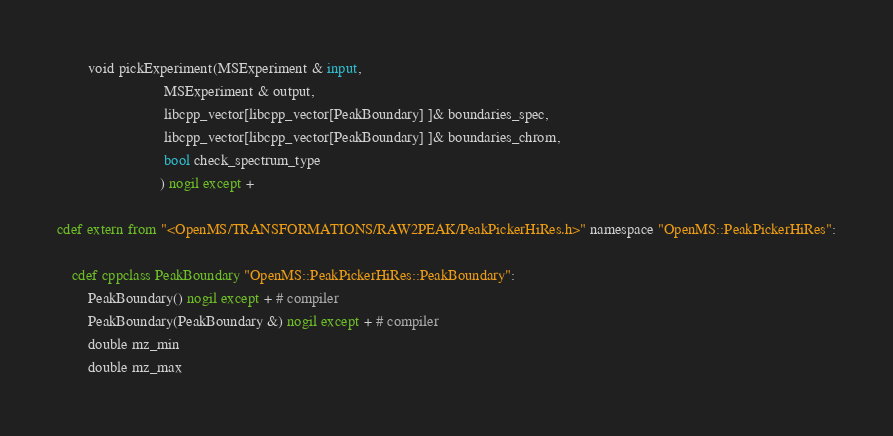Convert code to text. <code><loc_0><loc_0><loc_500><loc_500><_Cython_>
        void pickExperiment(MSExperiment & input,
                            MSExperiment & output,
                            libcpp_vector[libcpp_vector[PeakBoundary] ]& boundaries_spec,
                            libcpp_vector[libcpp_vector[PeakBoundary] ]& boundaries_chrom,
                            bool check_spectrum_type
                           ) nogil except +

cdef extern from "<OpenMS/TRANSFORMATIONS/RAW2PEAK/PeakPickerHiRes.h>" namespace "OpenMS::PeakPickerHiRes":
    
    cdef cppclass PeakBoundary "OpenMS::PeakPickerHiRes::PeakBoundary":
        PeakBoundary() nogil except + # compiler
        PeakBoundary(PeakBoundary &) nogil except + # compiler
        double mz_min
        double mz_max
</code> 